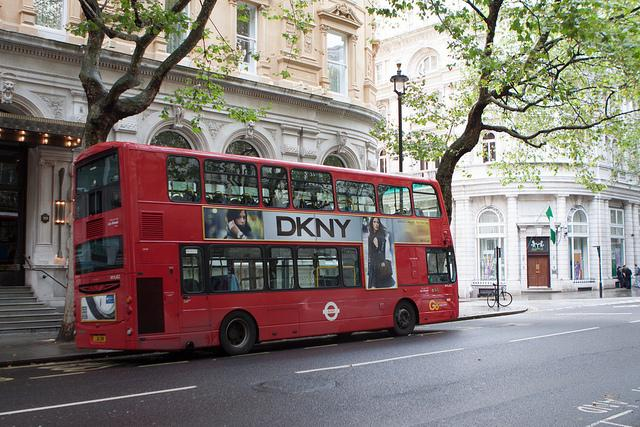What state is the company from whose logo appears on the bus? Please explain your reasoning. new york. The company has the state in its name. 